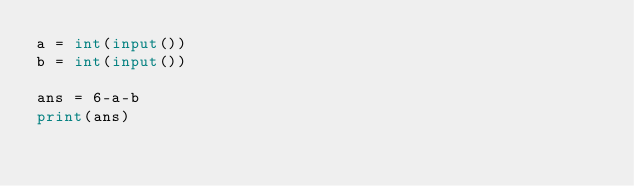Convert code to text. <code><loc_0><loc_0><loc_500><loc_500><_Python_>a = int(input())
b = int(input())

ans = 6-a-b
print(ans)
</code> 